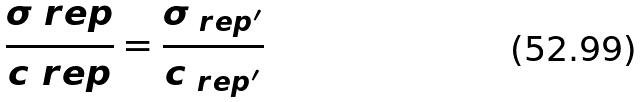Convert formula to latex. <formula><loc_0><loc_0><loc_500><loc_500>\frac { \sigma _ { \ } r e p } { c _ { \ } r e p } = \frac { \sigma _ { \ r e p ^ { \prime } } } { c _ { \ r e p ^ { \prime } } }</formula> 